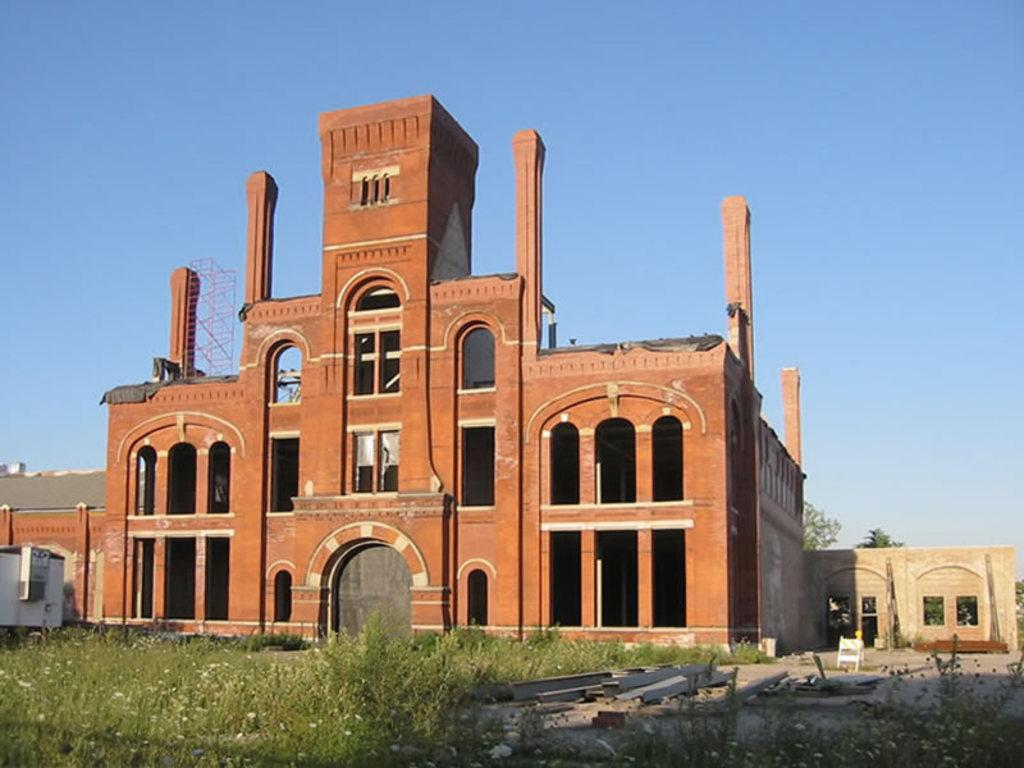What is the main subject of the picture? The main subject of the picture is a building. What is the current state of the building? The building is under construction. What type of surface is visible on the ground? There is grass on the floor. What is the condition of the sky in the picture? The sky is clear in the picture. What type of thought can be seen in the image? There are no thoughts visible in the image; it features a building under construction with grass on the ground and a clear sky. What kind of feast is being prepared in the image? There is no feast or preparation for a feast visible in the image. 